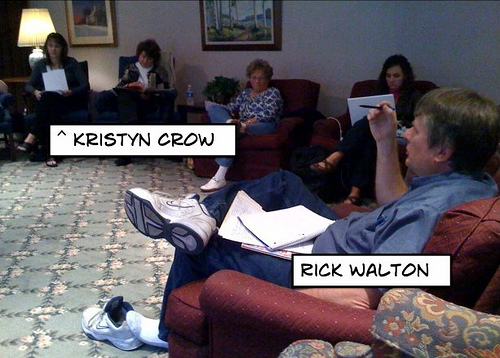Read all the text in this image. KRISTYN CROW RICK WALTON 